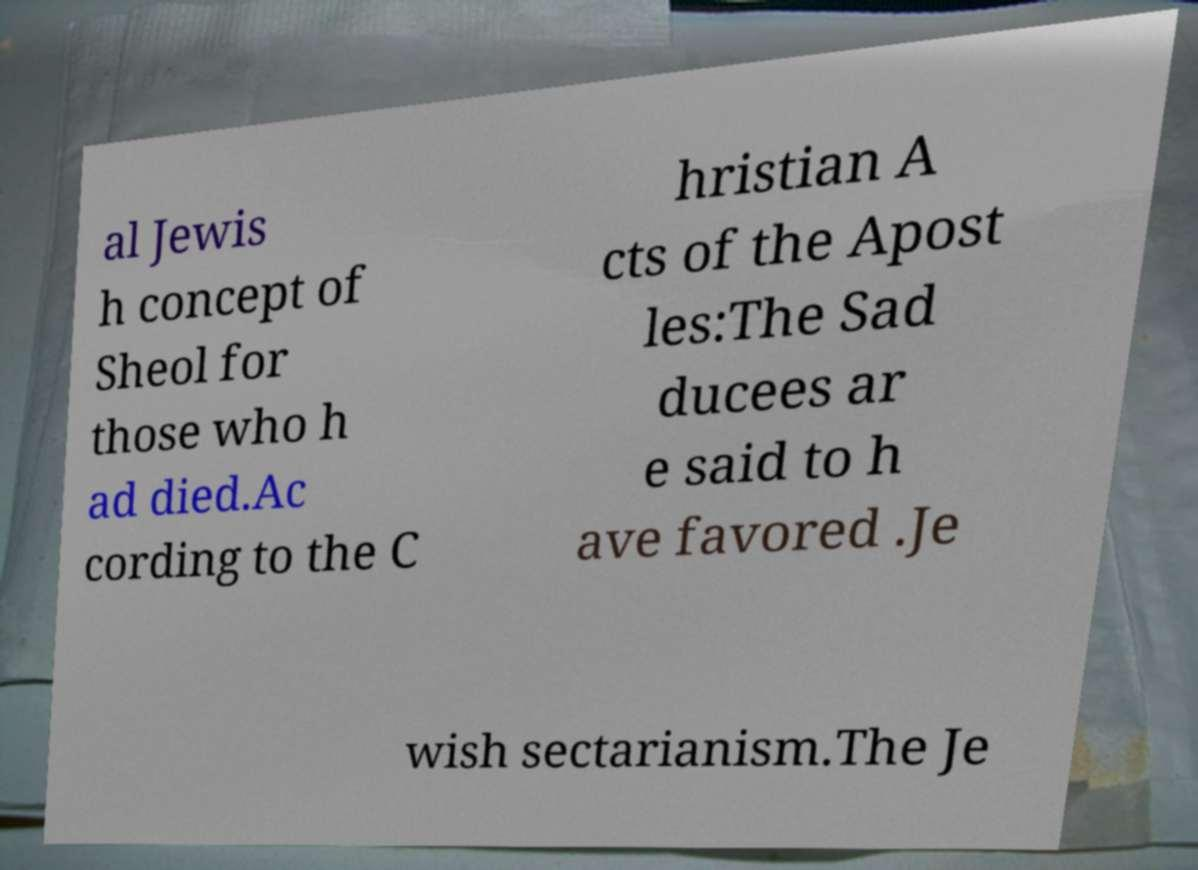What messages or text are displayed in this image? I need them in a readable, typed format. al Jewis h concept of Sheol for those who h ad died.Ac cording to the C hristian A cts of the Apost les:The Sad ducees ar e said to h ave favored .Je wish sectarianism.The Je 